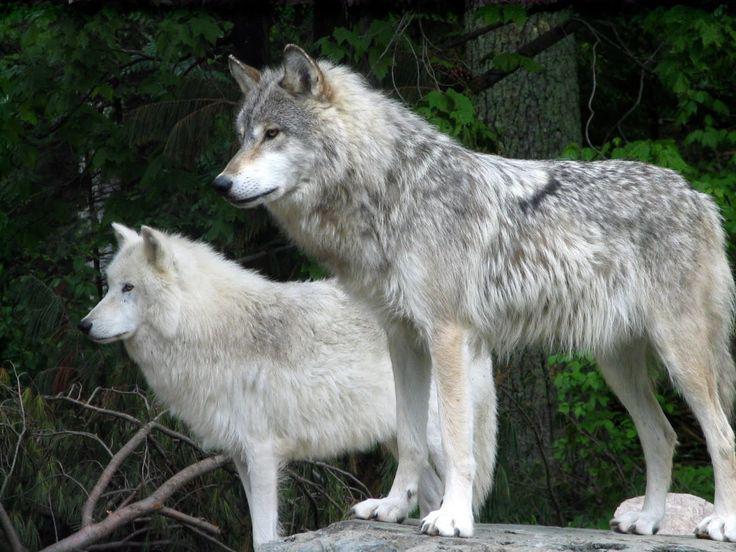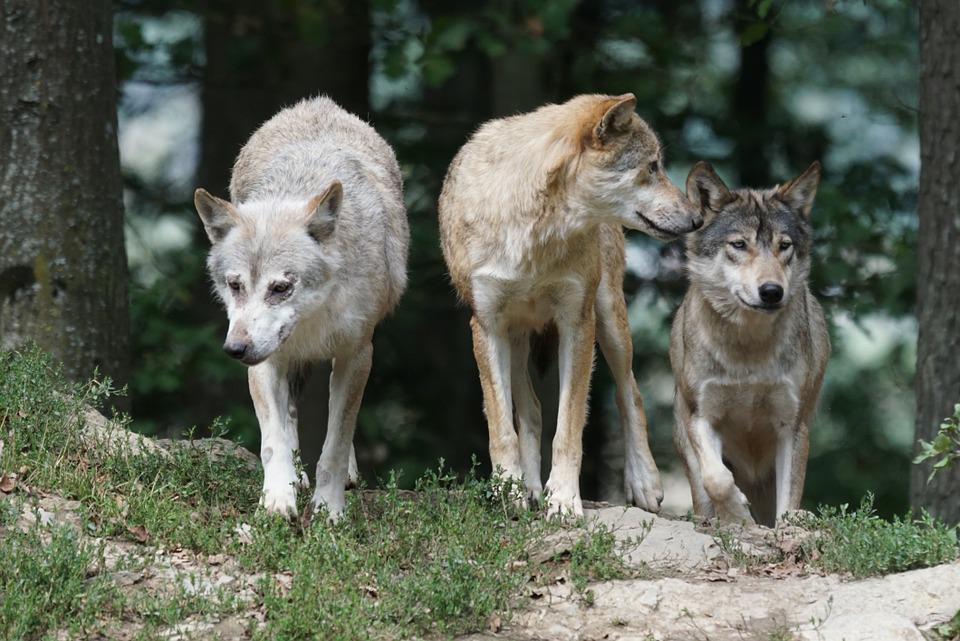The first image is the image on the left, the second image is the image on the right. Assess this claim about the two images: "There are at most 3 wolves.". Correct or not? Answer yes or no. No. The first image is the image on the left, the second image is the image on the right. Examine the images to the left and right. Is the description "You can clearly see there are more than three wolves or dogs." accurate? Answer yes or no. Yes. 